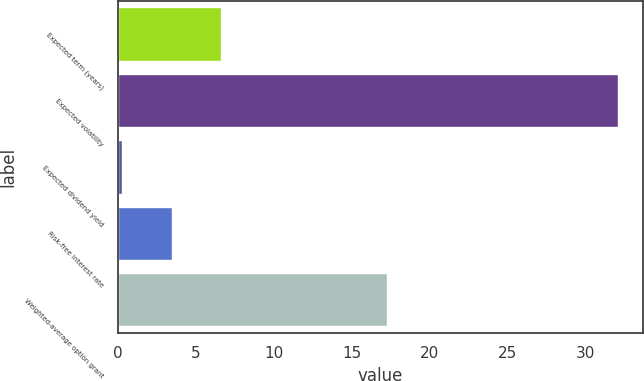Convert chart. <chart><loc_0><loc_0><loc_500><loc_500><bar_chart><fcel>Expected term (years)<fcel>Expected volatility<fcel>Expected dividend yield<fcel>Risk-free interest rate<fcel>Weighted-average option grant<nl><fcel>6.65<fcel>32.1<fcel>0.29<fcel>3.47<fcel>17.27<nl></chart> 